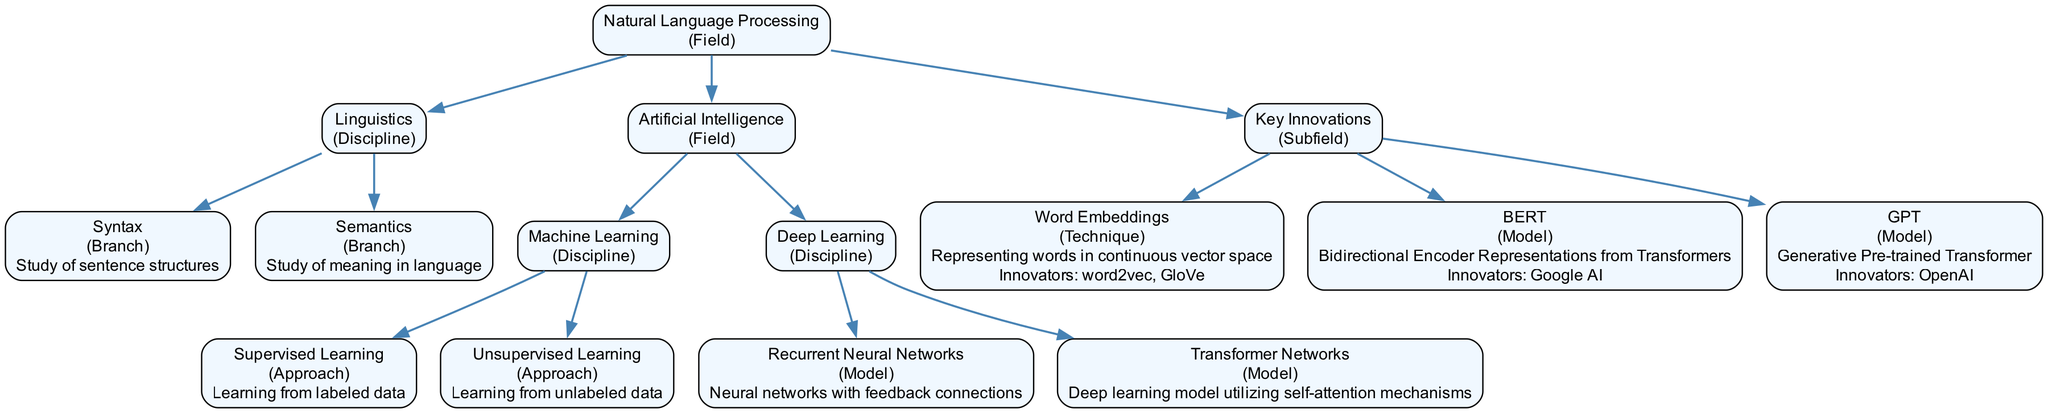What is the main field represented in the diagram? The diagram centers around "Natural Language Processing," which is identified at the root node as the primary field.
Answer: Natural Language Processing How many branches are under the "Artificial Intelligence" discipline? Under the "Artificial Intelligence" discipline, there are two branches presented: "Machine Learning" and "Deep Learning." This can be counted directly from the children of the "Artificial Intelligence" node.
Answer: 2 What type of technique is "Word Embeddings"? "Word Embeddings" is classified as a technique within the "Key Innovations" subfield, as indicated by its type property in the diagram.
Answer: Technique Who is associated with the innovation of "BERT"? The innovators of "BERT" are listed as "Google AI" in the diagram. This information is directly extracted from the node's properties.
Answer: Google AI Which model uses self-attention mechanisms? The "Transformer Networks" model is specifically noted for utilizing self-attention mechanisms, as described in the diagram under its description.
Answer: Transformer Networks Is "Syntax" a discipline or a branch? "Syntax" is categorized as a branch under the "Linguistics" discipline. This relationship is confirmed by following the structure from "Natural Language Processing" to its children.
Answer: Branch What type of approach is "Recurrent Neural Networks"? "Recurrent Neural Networks" is identified as a model under the discipline of "Deep Learning," specifically categorized under models rather than approaches.
Answer: Model What learning method deals with unlabeled data? The method that deals with unlabeled data is "Unsupervised Learning," which is explicitly stated under the "Machine Learning" discipline in the diagram.
Answer: Unsupervised Learning What is the relationship between "BERT" and "Natural Language Processing"? "BERT" is a model that falls under the "Key Innovations" subfield within the broader field of "Natural Language Processing." This illustrates a hierarchical relationship.
Answer: Model under Key Innovations 